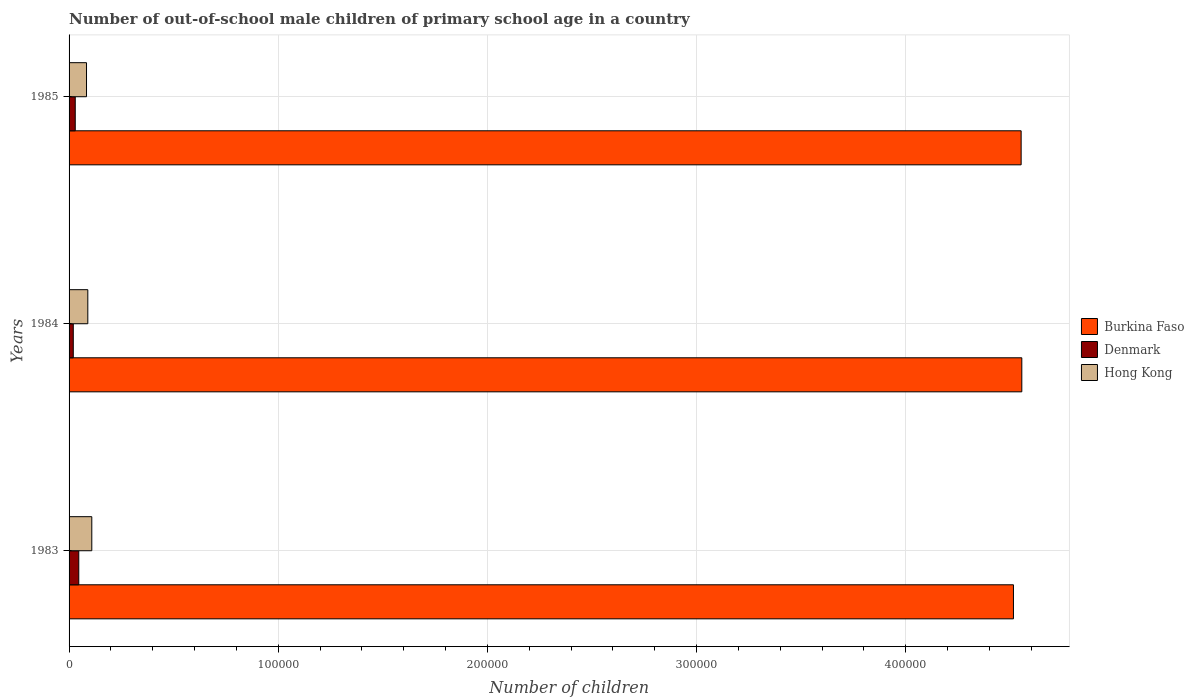How many different coloured bars are there?
Offer a very short reply. 3. Are the number of bars per tick equal to the number of legend labels?
Give a very brief answer. Yes. How many bars are there on the 3rd tick from the top?
Ensure brevity in your answer.  3. What is the number of out-of-school male children in Hong Kong in 1984?
Ensure brevity in your answer.  8963. Across all years, what is the maximum number of out-of-school male children in Denmark?
Provide a short and direct response. 4645. Across all years, what is the minimum number of out-of-school male children in Hong Kong?
Give a very brief answer. 8341. What is the total number of out-of-school male children in Burkina Faso in the graph?
Your answer should be very brief. 1.36e+06. What is the difference between the number of out-of-school male children in Hong Kong in 1983 and that in 1984?
Provide a short and direct response. 1901. What is the difference between the number of out-of-school male children in Denmark in 1985 and the number of out-of-school male children in Burkina Faso in 1983?
Your answer should be compact. -4.49e+05. What is the average number of out-of-school male children in Burkina Faso per year?
Your response must be concise. 4.54e+05. In the year 1983, what is the difference between the number of out-of-school male children in Denmark and number of out-of-school male children in Burkina Faso?
Your answer should be compact. -4.47e+05. What is the ratio of the number of out-of-school male children in Denmark in 1984 to that in 1985?
Ensure brevity in your answer.  0.68. What is the difference between the highest and the second highest number of out-of-school male children in Hong Kong?
Give a very brief answer. 1901. What is the difference between the highest and the lowest number of out-of-school male children in Burkina Faso?
Make the answer very short. 3992. Is the sum of the number of out-of-school male children in Hong Kong in 1983 and 1985 greater than the maximum number of out-of-school male children in Burkina Faso across all years?
Offer a terse response. No. What does the 3rd bar from the bottom in 1985 represents?
Provide a succinct answer. Hong Kong. How many bars are there?
Make the answer very short. 9. Does the graph contain any zero values?
Give a very brief answer. No. Where does the legend appear in the graph?
Your answer should be compact. Center right. How are the legend labels stacked?
Offer a terse response. Vertical. What is the title of the graph?
Give a very brief answer. Number of out-of-school male children of primary school age in a country. What is the label or title of the X-axis?
Offer a very short reply. Number of children. What is the label or title of the Y-axis?
Provide a succinct answer. Years. What is the Number of children of Burkina Faso in 1983?
Keep it short and to the point. 4.51e+05. What is the Number of children of Denmark in 1983?
Your response must be concise. 4645. What is the Number of children of Hong Kong in 1983?
Give a very brief answer. 1.09e+04. What is the Number of children of Burkina Faso in 1984?
Your answer should be very brief. 4.55e+05. What is the Number of children in Denmark in 1984?
Provide a short and direct response. 2010. What is the Number of children in Hong Kong in 1984?
Your response must be concise. 8963. What is the Number of children in Burkina Faso in 1985?
Provide a succinct answer. 4.55e+05. What is the Number of children of Denmark in 1985?
Ensure brevity in your answer.  2951. What is the Number of children in Hong Kong in 1985?
Provide a succinct answer. 8341. Across all years, what is the maximum Number of children in Burkina Faso?
Your answer should be very brief. 4.55e+05. Across all years, what is the maximum Number of children of Denmark?
Offer a terse response. 4645. Across all years, what is the maximum Number of children of Hong Kong?
Keep it short and to the point. 1.09e+04. Across all years, what is the minimum Number of children in Burkina Faso?
Make the answer very short. 4.51e+05. Across all years, what is the minimum Number of children of Denmark?
Offer a very short reply. 2010. Across all years, what is the minimum Number of children in Hong Kong?
Keep it short and to the point. 8341. What is the total Number of children in Burkina Faso in the graph?
Provide a short and direct response. 1.36e+06. What is the total Number of children of Denmark in the graph?
Your response must be concise. 9606. What is the total Number of children in Hong Kong in the graph?
Your answer should be very brief. 2.82e+04. What is the difference between the Number of children in Burkina Faso in 1983 and that in 1984?
Offer a very short reply. -3992. What is the difference between the Number of children of Denmark in 1983 and that in 1984?
Offer a terse response. 2635. What is the difference between the Number of children of Hong Kong in 1983 and that in 1984?
Your answer should be very brief. 1901. What is the difference between the Number of children of Burkina Faso in 1983 and that in 1985?
Your response must be concise. -3673. What is the difference between the Number of children in Denmark in 1983 and that in 1985?
Ensure brevity in your answer.  1694. What is the difference between the Number of children in Hong Kong in 1983 and that in 1985?
Keep it short and to the point. 2523. What is the difference between the Number of children in Burkina Faso in 1984 and that in 1985?
Offer a very short reply. 319. What is the difference between the Number of children of Denmark in 1984 and that in 1985?
Provide a short and direct response. -941. What is the difference between the Number of children in Hong Kong in 1984 and that in 1985?
Offer a very short reply. 622. What is the difference between the Number of children of Burkina Faso in 1983 and the Number of children of Denmark in 1984?
Provide a succinct answer. 4.49e+05. What is the difference between the Number of children in Burkina Faso in 1983 and the Number of children in Hong Kong in 1984?
Offer a terse response. 4.43e+05. What is the difference between the Number of children of Denmark in 1983 and the Number of children of Hong Kong in 1984?
Give a very brief answer. -4318. What is the difference between the Number of children in Burkina Faso in 1983 and the Number of children in Denmark in 1985?
Offer a terse response. 4.49e+05. What is the difference between the Number of children of Burkina Faso in 1983 and the Number of children of Hong Kong in 1985?
Provide a short and direct response. 4.43e+05. What is the difference between the Number of children in Denmark in 1983 and the Number of children in Hong Kong in 1985?
Your response must be concise. -3696. What is the difference between the Number of children in Burkina Faso in 1984 and the Number of children in Denmark in 1985?
Make the answer very short. 4.53e+05. What is the difference between the Number of children of Burkina Faso in 1984 and the Number of children of Hong Kong in 1985?
Your answer should be very brief. 4.47e+05. What is the difference between the Number of children of Denmark in 1984 and the Number of children of Hong Kong in 1985?
Your answer should be very brief. -6331. What is the average Number of children in Burkina Faso per year?
Offer a very short reply. 4.54e+05. What is the average Number of children in Denmark per year?
Make the answer very short. 3202. What is the average Number of children of Hong Kong per year?
Provide a succinct answer. 9389.33. In the year 1983, what is the difference between the Number of children in Burkina Faso and Number of children in Denmark?
Provide a short and direct response. 4.47e+05. In the year 1983, what is the difference between the Number of children of Burkina Faso and Number of children of Hong Kong?
Keep it short and to the point. 4.41e+05. In the year 1983, what is the difference between the Number of children of Denmark and Number of children of Hong Kong?
Provide a succinct answer. -6219. In the year 1984, what is the difference between the Number of children of Burkina Faso and Number of children of Denmark?
Offer a terse response. 4.53e+05. In the year 1984, what is the difference between the Number of children of Burkina Faso and Number of children of Hong Kong?
Make the answer very short. 4.47e+05. In the year 1984, what is the difference between the Number of children in Denmark and Number of children in Hong Kong?
Offer a terse response. -6953. In the year 1985, what is the difference between the Number of children in Burkina Faso and Number of children in Denmark?
Provide a succinct answer. 4.52e+05. In the year 1985, what is the difference between the Number of children in Burkina Faso and Number of children in Hong Kong?
Keep it short and to the point. 4.47e+05. In the year 1985, what is the difference between the Number of children in Denmark and Number of children in Hong Kong?
Your answer should be very brief. -5390. What is the ratio of the Number of children of Burkina Faso in 1983 to that in 1984?
Provide a succinct answer. 0.99. What is the ratio of the Number of children of Denmark in 1983 to that in 1984?
Provide a short and direct response. 2.31. What is the ratio of the Number of children of Hong Kong in 1983 to that in 1984?
Give a very brief answer. 1.21. What is the ratio of the Number of children of Burkina Faso in 1983 to that in 1985?
Your answer should be very brief. 0.99. What is the ratio of the Number of children in Denmark in 1983 to that in 1985?
Your response must be concise. 1.57. What is the ratio of the Number of children of Hong Kong in 1983 to that in 1985?
Provide a short and direct response. 1.3. What is the ratio of the Number of children of Denmark in 1984 to that in 1985?
Your response must be concise. 0.68. What is the ratio of the Number of children of Hong Kong in 1984 to that in 1985?
Offer a terse response. 1.07. What is the difference between the highest and the second highest Number of children of Burkina Faso?
Your response must be concise. 319. What is the difference between the highest and the second highest Number of children in Denmark?
Your response must be concise. 1694. What is the difference between the highest and the second highest Number of children in Hong Kong?
Make the answer very short. 1901. What is the difference between the highest and the lowest Number of children in Burkina Faso?
Keep it short and to the point. 3992. What is the difference between the highest and the lowest Number of children in Denmark?
Keep it short and to the point. 2635. What is the difference between the highest and the lowest Number of children in Hong Kong?
Your answer should be very brief. 2523. 